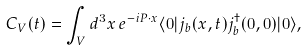Convert formula to latex. <formula><loc_0><loc_0><loc_500><loc_500>C _ { V } ( t ) = \int _ { V } d ^ { 3 } { x } \, e ^ { - i { P } \cdot { x } } \langle 0 | j _ { b } ( { x } , t ) j _ { b } ^ { \dagger } ( { 0 } , 0 ) | 0 \rangle ,</formula> 